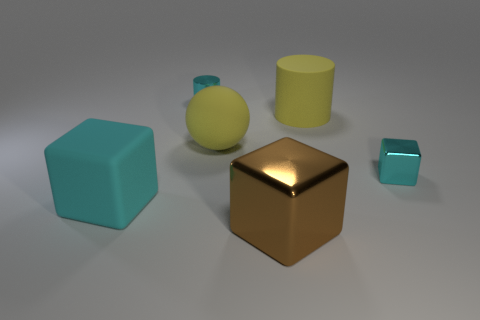Do the yellow matte ball and the cyan block right of the small shiny cylinder have the same size?
Ensure brevity in your answer.  No. How many matte objects are either tiny cylinders or cyan blocks?
Your answer should be very brief. 1. There is a large matte cube; is it the same color as the block that is behind the matte block?
Ensure brevity in your answer.  Yes. How big is the cyan cube right of the thing in front of the cyan rubber object to the left of the matte ball?
Keep it short and to the point. Small. How many other objects are the same shape as the large brown shiny object?
Provide a short and direct response. 2. Do the tiny thing on the right side of the brown shiny cube and the cyan thing in front of the small cyan metallic cube have the same shape?
Give a very brief answer. Yes. How many spheres are large purple rubber objects or large yellow objects?
Keep it short and to the point. 1. There is a cyan cube that is on the left side of the tiny cyan cube that is on the right side of the small object that is behind the tiny block; what is its material?
Offer a terse response. Rubber. How many other things are the same size as the brown metal thing?
Provide a short and direct response. 3. There is a metal thing that is the same color as the small cylinder; what is its size?
Give a very brief answer. Small. 